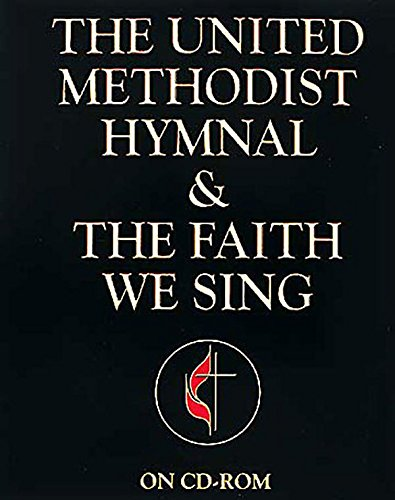Could you tell me more about the significance of the cross logo shown on the book cover? The cross logo on the cover symbolizes Christianity, a central element of the hymnal. It reflects the spiritual grounding and religious identity of this book, linking it closely with Christian worship practices. 